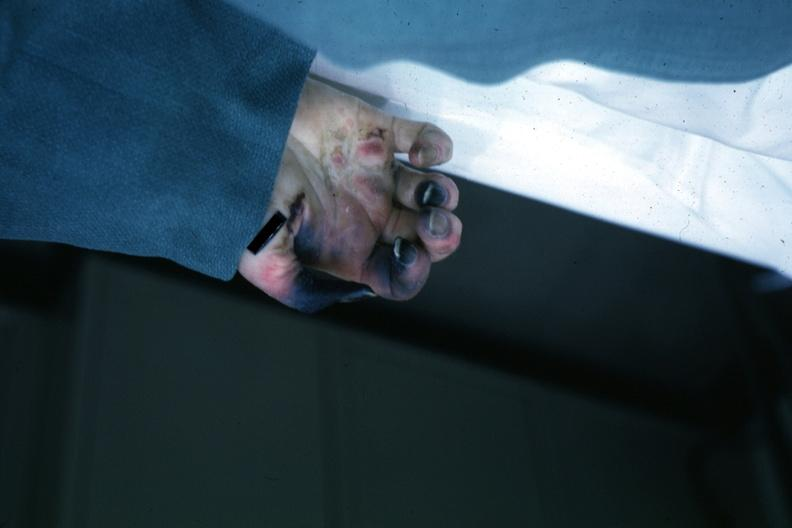re x-ray intramyocardial arteries present?
Answer the question using a single word or phrase. No 